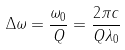Convert formula to latex. <formula><loc_0><loc_0><loc_500><loc_500>\Delta \omega = \frac { \omega _ { 0 } } { Q } = \frac { 2 \pi c } { Q \lambda _ { 0 } }</formula> 